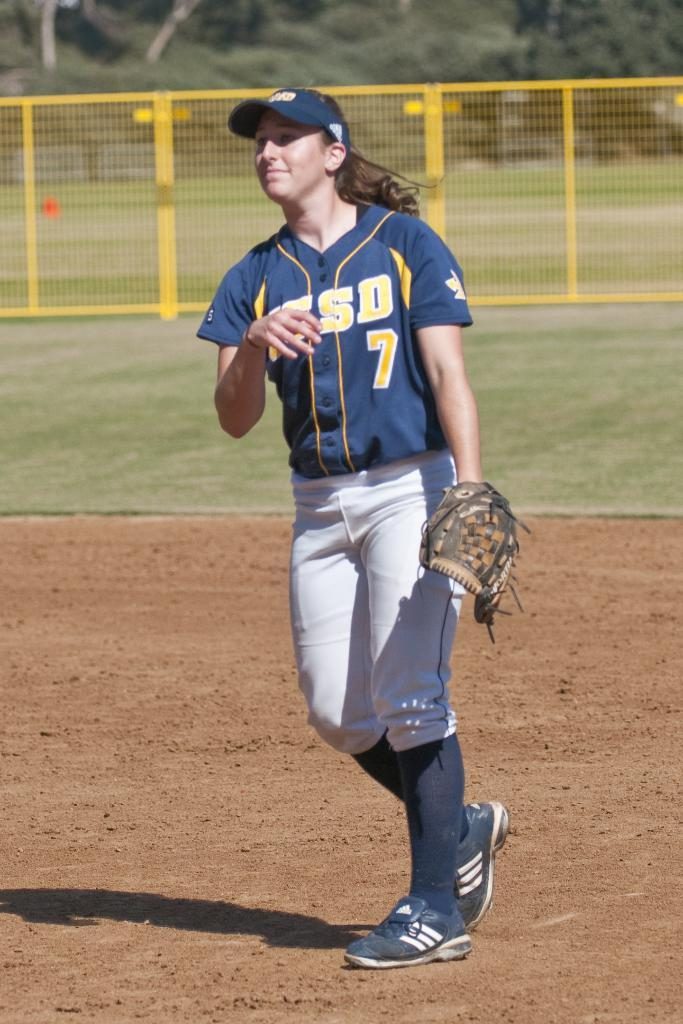<image>
Render a clear and concise summary of the photo. A female ball player on a dirt field with a UCSD jersey on 